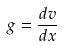<formula> <loc_0><loc_0><loc_500><loc_500>g = \frac { d v } { d x }</formula> 